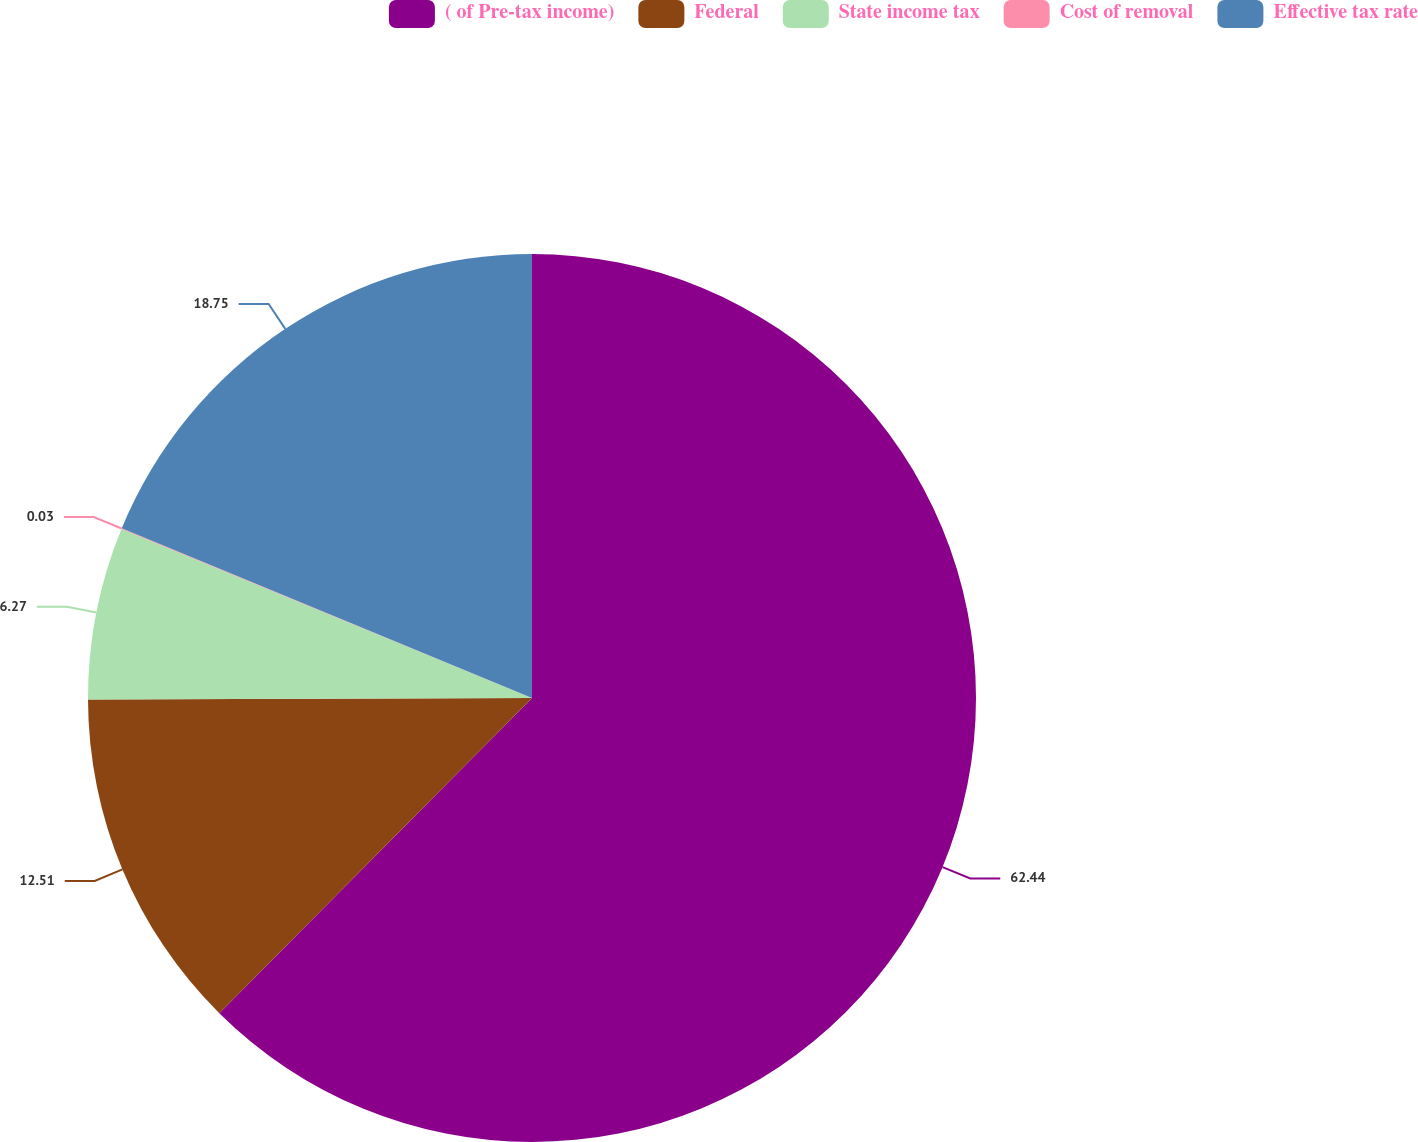Convert chart. <chart><loc_0><loc_0><loc_500><loc_500><pie_chart><fcel>( of Pre-tax income)<fcel>Federal<fcel>State income tax<fcel>Cost of removal<fcel>Effective tax rate<nl><fcel>62.43%<fcel>12.51%<fcel>6.27%<fcel>0.03%<fcel>18.75%<nl></chart> 